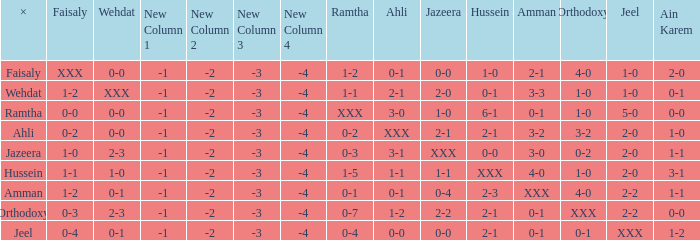What is x when faisaly is 0-0? Ramtha. 